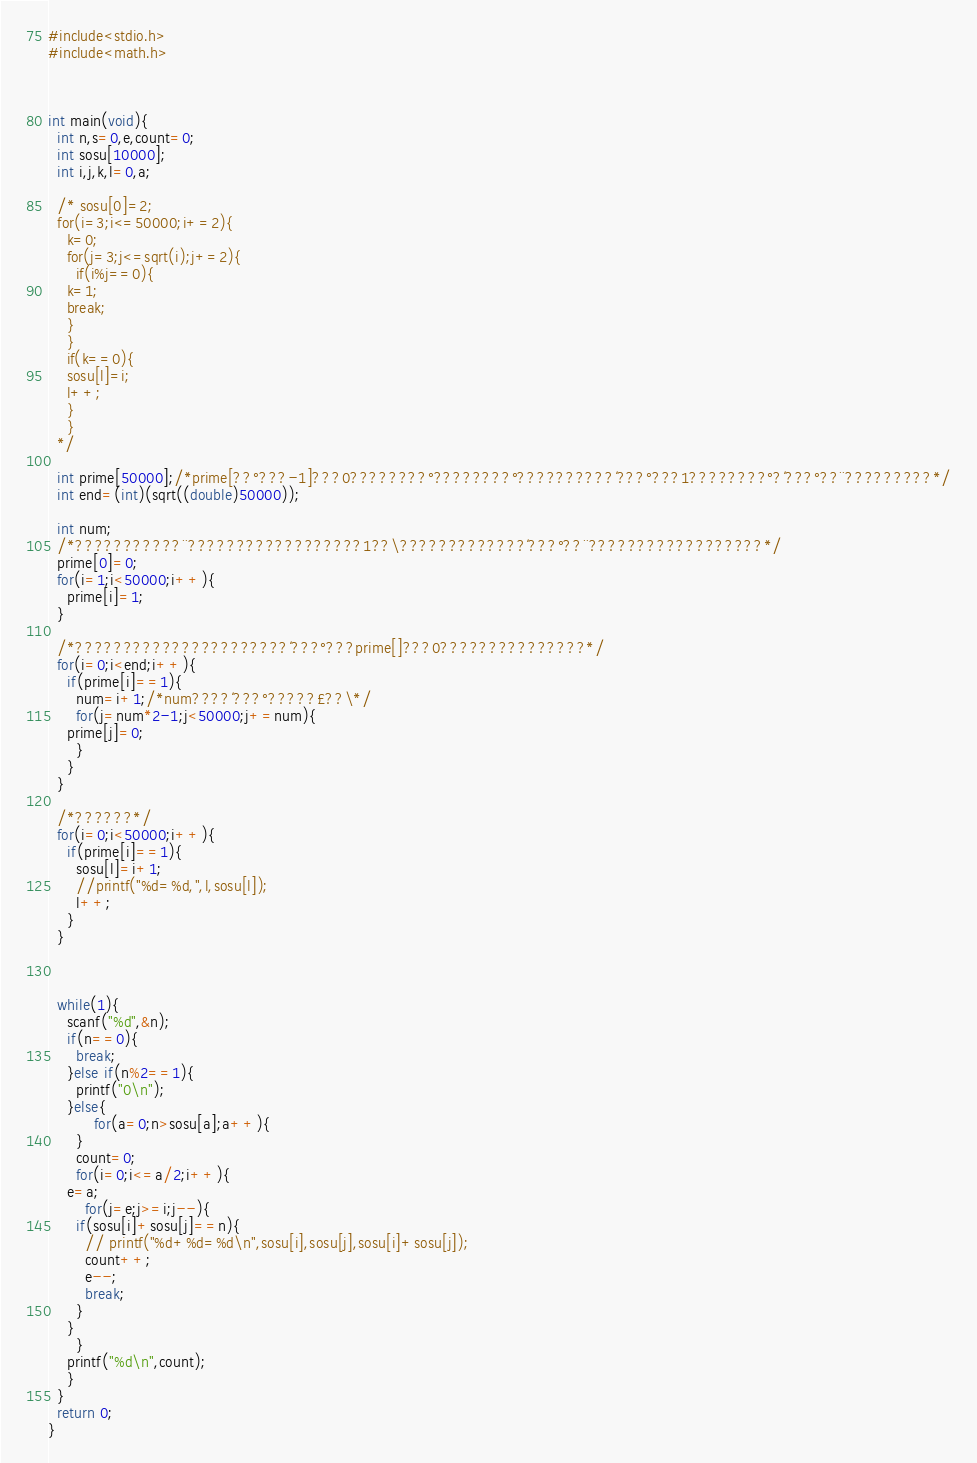Convert code to text. <code><loc_0><loc_0><loc_500><loc_500><_C_>#include<stdio.h>
#include<math.h>



int main(void){
  int n,s=0,e,count=0;
  int sosu[10000];
  int i,j,k,l=0,a;

  /* sosu[0]=2;
  for(i=3;i<=50000;i+=2){
    k=0;
    for(j=3;j<=sqrt(i);j+=2){
      if(i%j==0){
	k=1;
	break;
	}
	}
	if(k==0){
	sosu[l]=i;
	l++;
	}
	}
  */
  
  int prime[50000];/*prime[??°???-1]???0????????°????????°??????????´???°???1????????°?´???°??¨?????????*/
  int end=(int)(sqrt((double)50000));
   
  int num;
  /*???????????¨??????????????????1??\?????????????´???°??¨??????????????????*/
  prime[0]=0;
  for(i=1;i<50000;i++){
    prime[i]=1;
  }
 
  /*??????????????????????´???°???prime[]???0???????????????*/
  for(i=0;i<end;i++){
    if(prime[i]==1){
      num=i+1;/*num????´???°?????£??\*/
      for(j=num*2-1;j<50000;j+=num){
	prime[j]=0;
      }
    }
  }
 
  /*??????*/
  for(i=0;i<50000;i++){
    if(prime[i]==1){
      sosu[l]=i+1;
      //printf("%d=%d,",l,sosu[l]);
      l++;
    }
  }



  while(1){
    scanf("%d",&n);
    if(n==0){
      break;
    }else if(n%2==1){
      printf("0\n");
    }else{
          for(a=0;n>sosu[a];a++){
	  }
      count=0;
      for(i=0;i<=a/2;i++){
	e=a;
       	for(j=e;j>=i;j--){
	  if(sosu[i]+sosu[j]==n){
	    // printf("%d+%d=%d\n",sosu[i],sosu[j],sosu[i]+sosu[j]);
	    count++;
	    e--;
	    break;
	  }
	}
      }
    printf("%d\n",count);
    }
  }
  return 0;
}</code> 